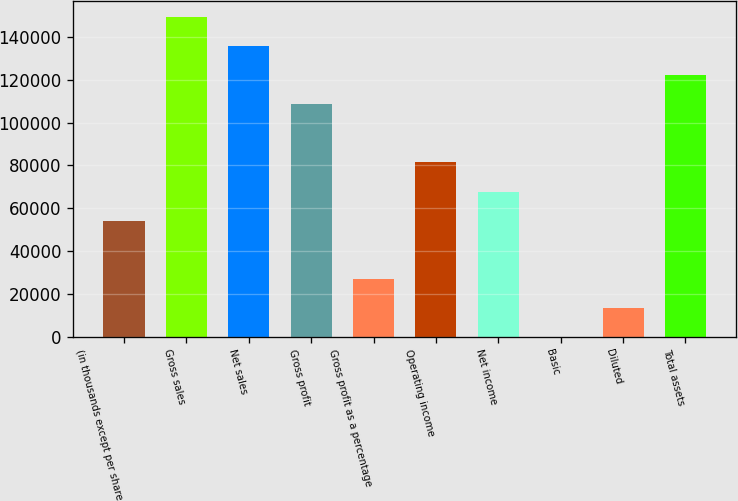<chart> <loc_0><loc_0><loc_500><loc_500><bar_chart><fcel>(in thousands except per share<fcel>Gross sales<fcel>Net sales<fcel>Gross profit<fcel>Gross profit as a percentage<fcel>Operating income<fcel>Net income<fcel>Basic<fcel>Diluted<fcel>Total assets<nl><fcel>54262<fcel>149220<fcel>135655<fcel>108524<fcel>27131<fcel>81393<fcel>67827.5<fcel>0.07<fcel>13565.6<fcel>122089<nl></chart> 